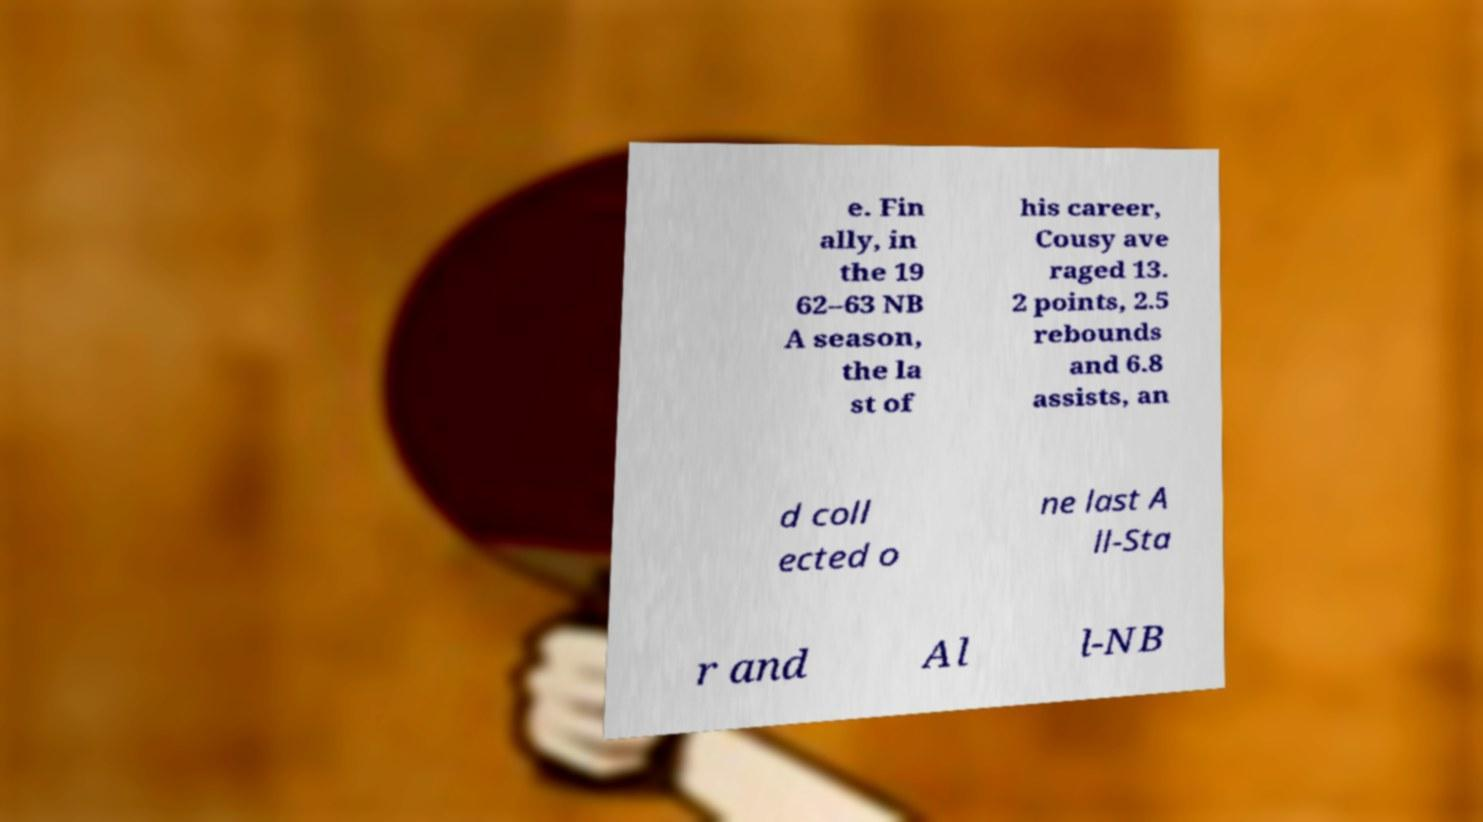Could you extract and type out the text from this image? e. Fin ally, in the 19 62–63 NB A season, the la st of his career, Cousy ave raged 13. 2 points, 2.5 rebounds and 6.8 assists, an d coll ected o ne last A ll-Sta r and Al l-NB 